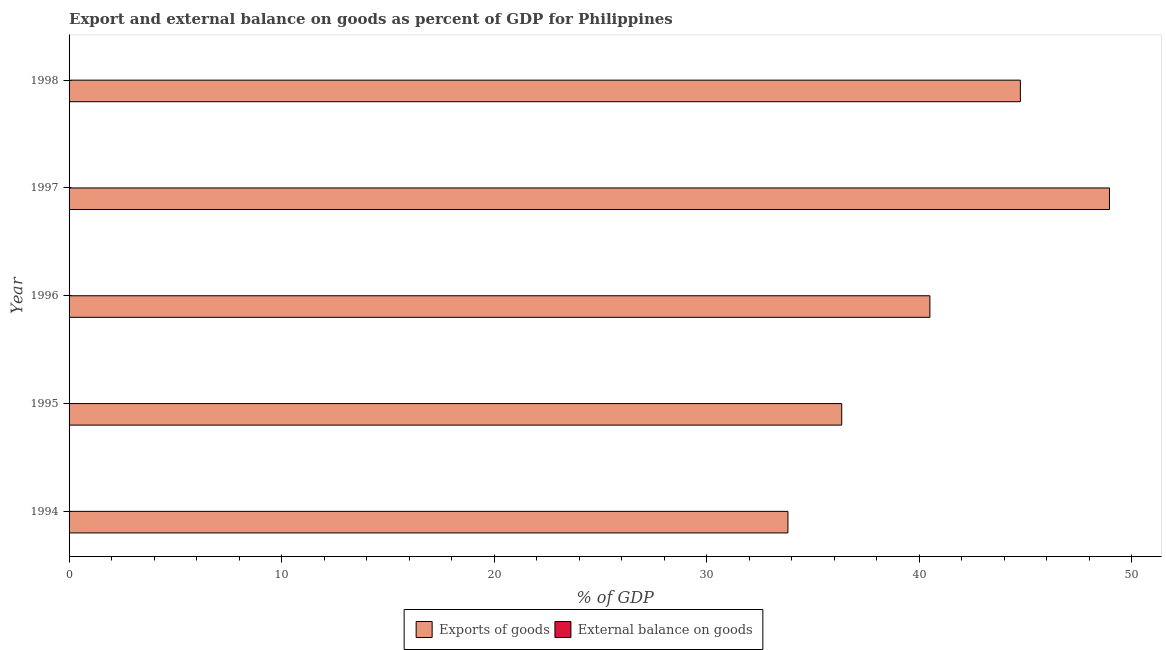Are the number of bars per tick equal to the number of legend labels?
Your answer should be compact. No. In how many cases, is the number of bars for a given year not equal to the number of legend labels?
Ensure brevity in your answer.  5. What is the export of goods as percentage of gdp in 1996?
Give a very brief answer. 40.51. Across all years, what is the maximum export of goods as percentage of gdp?
Keep it short and to the point. 48.96. Across all years, what is the minimum export of goods as percentage of gdp?
Provide a short and direct response. 33.83. What is the total external balance on goods as percentage of gdp in the graph?
Provide a short and direct response. 0. What is the difference between the export of goods as percentage of gdp in 1996 and that in 1997?
Your response must be concise. -8.45. What is the difference between the export of goods as percentage of gdp in 1998 and the external balance on goods as percentage of gdp in 1994?
Offer a terse response. 44.76. What is the average external balance on goods as percentage of gdp per year?
Offer a very short reply. 0. In how many years, is the external balance on goods as percentage of gdp greater than 32 %?
Keep it short and to the point. 0. What is the ratio of the export of goods as percentage of gdp in 1994 to that in 1996?
Offer a very short reply. 0.83. Is the export of goods as percentage of gdp in 1994 less than that in 1995?
Your answer should be very brief. Yes. What is the difference between the highest and the second highest export of goods as percentage of gdp?
Ensure brevity in your answer.  4.19. What is the difference between the highest and the lowest export of goods as percentage of gdp?
Keep it short and to the point. 15.13. In how many years, is the export of goods as percentage of gdp greater than the average export of goods as percentage of gdp taken over all years?
Your answer should be very brief. 2. Is the sum of the export of goods as percentage of gdp in 1996 and 1998 greater than the maximum external balance on goods as percentage of gdp across all years?
Your response must be concise. Yes. How many bars are there?
Offer a very short reply. 5. How many years are there in the graph?
Provide a short and direct response. 5. What is the difference between two consecutive major ticks on the X-axis?
Your response must be concise. 10. Are the values on the major ticks of X-axis written in scientific E-notation?
Keep it short and to the point. No. Does the graph contain any zero values?
Keep it short and to the point. Yes. How are the legend labels stacked?
Give a very brief answer. Horizontal. What is the title of the graph?
Give a very brief answer. Export and external balance on goods as percent of GDP for Philippines. Does "US$" appear as one of the legend labels in the graph?
Provide a succinct answer. No. What is the label or title of the X-axis?
Provide a short and direct response. % of GDP. What is the % of GDP in Exports of goods in 1994?
Give a very brief answer. 33.83. What is the % of GDP of Exports of goods in 1995?
Provide a short and direct response. 36.36. What is the % of GDP of External balance on goods in 1995?
Provide a succinct answer. 0. What is the % of GDP of Exports of goods in 1996?
Make the answer very short. 40.51. What is the % of GDP of External balance on goods in 1996?
Provide a succinct answer. 0. What is the % of GDP in Exports of goods in 1997?
Provide a succinct answer. 48.96. What is the % of GDP of Exports of goods in 1998?
Offer a very short reply. 44.76. Across all years, what is the maximum % of GDP of Exports of goods?
Give a very brief answer. 48.96. Across all years, what is the minimum % of GDP in Exports of goods?
Make the answer very short. 33.83. What is the total % of GDP of Exports of goods in the graph?
Your answer should be very brief. 204.41. What is the difference between the % of GDP of Exports of goods in 1994 and that in 1995?
Make the answer very short. -2.53. What is the difference between the % of GDP in Exports of goods in 1994 and that in 1996?
Keep it short and to the point. -6.68. What is the difference between the % of GDP of Exports of goods in 1994 and that in 1997?
Give a very brief answer. -15.13. What is the difference between the % of GDP in Exports of goods in 1994 and that in 1998?
Ensure brevity in your answer.  -10.94. What is the difference between the % of GDP in Exports of goods in 1995 and that in 1996?
Your response must be concise. -4.15. What is the difference between the % of GDP of Exports of goods in 1995 and that in 1997?
Make the answer very short. -12.6. What is the difference between the % of GDP in Exports of goods in 1995 and that in 1998?
Your answer should be very brief. -8.41. What is the difference between the % of GDP in Exports of goods in 1996 and that in 1997?
Provide a short and direct response. -8.45. What is the difference between the % of GDP in Exports of goods in 1996 and that in 1998?
Give a very brief answer. -4.26. What is the difference between the % of GDP of Exports of goods in 1997 and that in 1998?
Your response must be concise. 4.19. What is the average % of GDP of Exports of goods per year?
Give a very brief answer. 40.88. What is the ratio of the % of GDP in Exports of goods in 1994 to that in 1995?
Your response must be concise. 0.93. What is the ratio of the % of GDP of Exports of goods in 1994 to that in 1996?
Your response must be concise. 0.84. What is the ratio of the % of GDP in Exports of goods in 1994 to that in 1997?
Make the answer very short. 0.69. What is the ratio of the % of GDP of Exports of goods in 1994 to that in 1998?
Give a very brief answer. 0.76. What is the ratio of the % of GDP in Exports of goods in 1995 to that in 1996?
Your response must be concise. 0.9. What is the ratio of the % of GDP of Exports of goods in 1995 to that in 1997?
Your response must be concise. 0.74. What is the ratio of the % of GDP in Exports of goods in 1995 to that in 1998?
Ensure brevity in your answer.  0.81. What is the ratio of the % of GDP in Exports of goods in 1996 to that in 1997?
Provide a short and direct response. 0.83. What is the ratio of the % of GDP of Exports of goods in 1996 to that in 1998?
Your answer should be very brief. 0.9. What is the ratio of the % of GDP in Exports of goods in 1997 to that in 1998?
Your response must be concise. 1.09. What is the difference between the highest and the second highest % of GDP of Exports of goods?
Provide a short and direct response. 4.19. What is the difference between the highest and the lowest % of GDP in Exports of goods?
Your answer should be very brief. 15.13. 